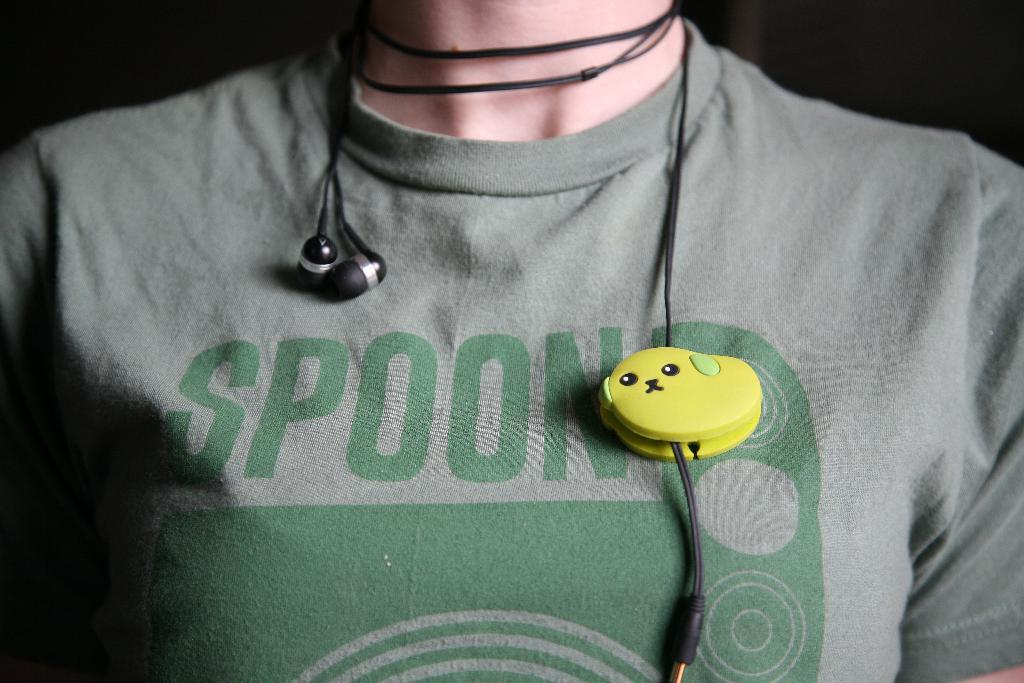Who or what is present in the image? There is a person in the image. What is the person wearing? The person is wearing a gray t-shirt. What can be seen in addition to the person? Earphones are visible in the image. What type of stitch is used to create the pattern on the person's t-shirt? There is no pattern visible on the person's t-shirt in the image, so it is not possible to determine the type of stitch used. 